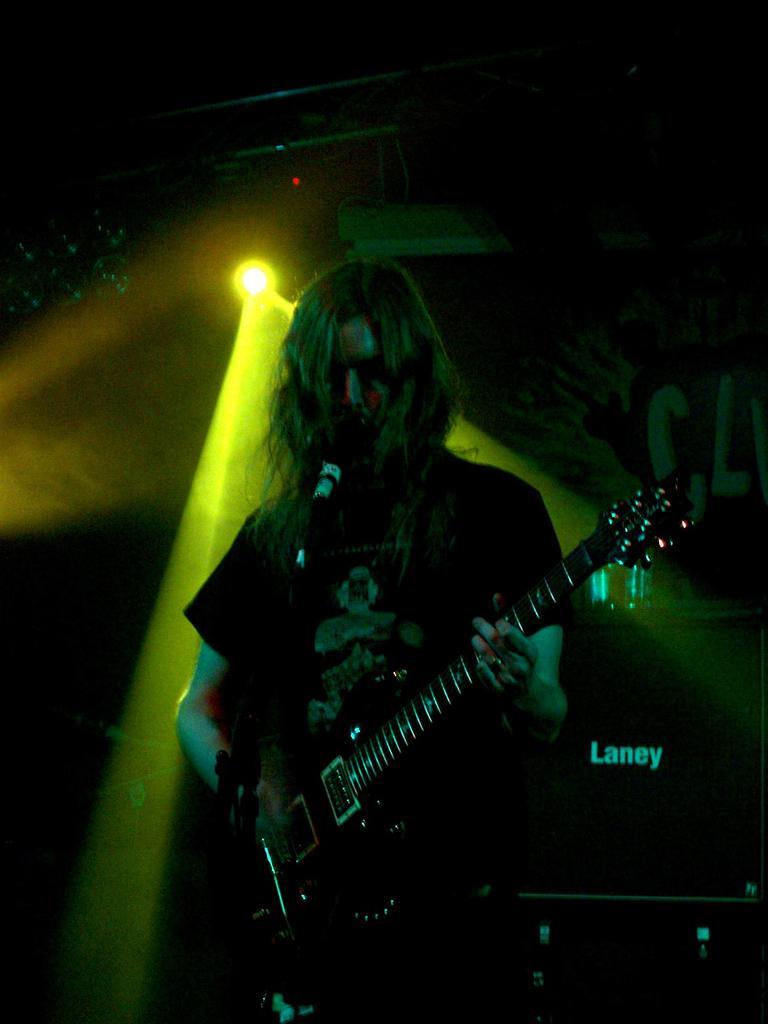Describe this image in one or two sentences. In this picture I can see a person is playing a guitar. The person is wearing t shirt and standing in front of a microphone. In the background I can see stage light and the image is dark. 